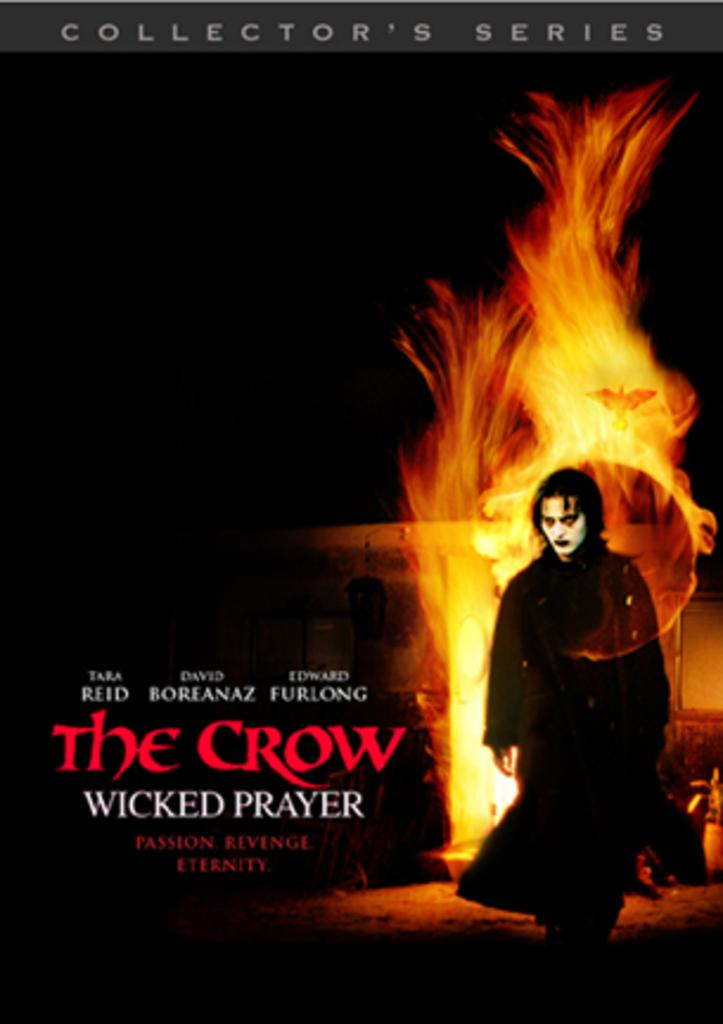<image>
Share a concise interpretation of the image provided. A poster advertising the movie The Crow, Wicked Prayer 